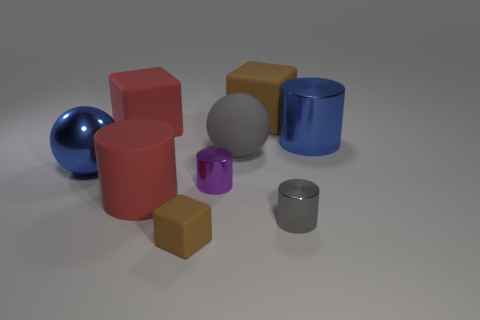Add 1 small purple cylinders. How many objects exist? 10 Subtract all large shiny cylinders. How many cylinders are left? 3 Subtract all blue balls. How many brown blocks are left? 2 Subtract all small rubber cubes. Subtract all big brown matte objects. How many objects are left? 7 Add 4 big shiny cylinders. How many big shiny cylinders are left? 5 Add 2 large shiny cylinders. How many large shiny cylinders exist? 3 Subtract all red cylinders. How many cylinders are left? 3 Subtract 0 red spheres. How many objects are left? 9 Subtract all balls. How many objects are left? 7 Subtract 2 blocks. How many blocks are left? 1 